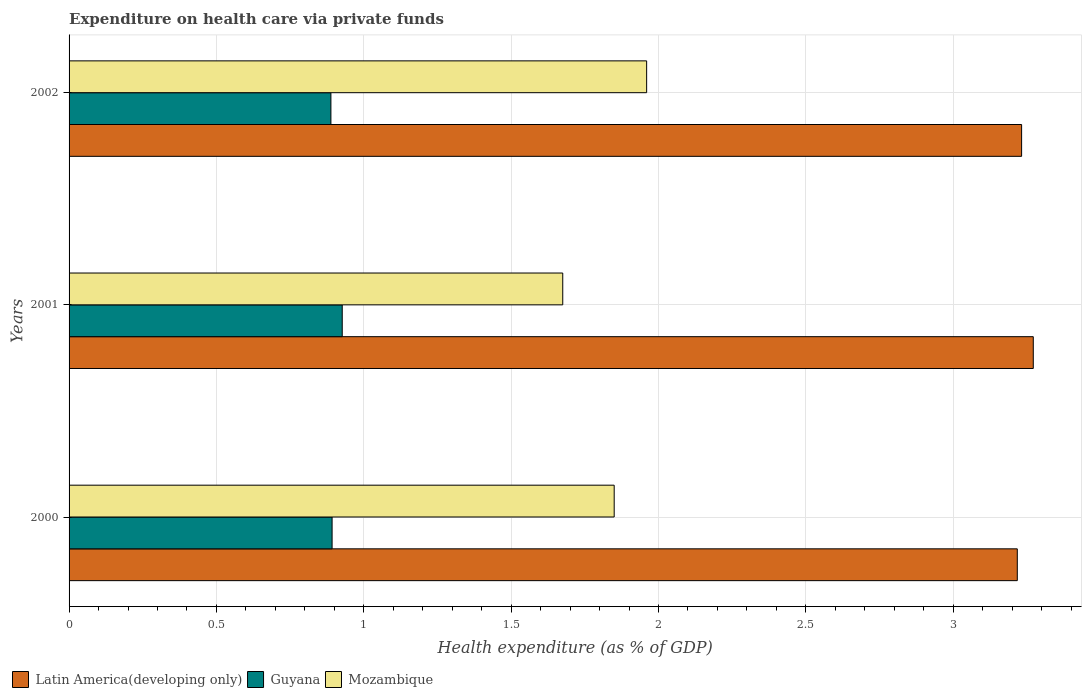How many different coloured bars are there?
Ensure brevity in your answer.  3. How many groups of bars are there?
Give a very brief answer. 3. How many bars are there on the 2nd tick from the top?
Ensure brevity in your answer.  3. In how many cases, is the number of bars for a given year not equal to the number of legend labels?
Give a very brief answer. 0. What is the expenditure made on health care in Guyana in 2000?
Give a very brief answer. 0.89. Across all years, what is the maximum expenditure made on health care in Guyana?
Keep it short and to the point. 0.93. Across all years, what is the minimum expenditure made on health care in Mozambique?
Make the answer very short. 1.68. In which year was the expenditure made on health care in Latin America(developing only) maximum?
Your response must be concise. 2001. What is the total expenditure made on health care in Guyana in the graph?
Provide a short and direct response. 2.71. What is the difference between the expenditure made on health care in Mozambique in 2000 and that in 2001?
Your answer should be very brief. 0.17. What is the difference between the expenditure made on health care in Guyana in 2000 and the expenditure made on health care in Latin America(developing only) in 2002?
Provide a succinct answer. -2.34. What is the average expenditure made on health care in Guyana per year?
Make the answer very short. 0.9. In the year 2001, what is the difference between the expenditure made on health care in Mozambique and expenditure made on health care in Latin America(developing only)?
Keep it short and to the point. -1.6. In how many years, is the expenditure made on health care in Guyana greater than 2.5 %?
Offer a terse response. 0. What is the ratio of the expenditure made on health care in Mozambique in 2000 to that in 2002?
Keep it short and to the point. 0.94. Is the expenditure made on health care in Latin America(developing only) in 2001 less than that in 2002?
Ensure brevity in your answer.  No. What is the difference between the highest and the second highest expenditure made on health care in Mozambique?
Give a very brief answer. 0.11. What is the difference between the highest and the lowest expenditure made on health care in Mozambique?
Make the answer very short. 0.28. In how many years, is the expenditure made on health care in Mozambique greater than the average expenditure made on health care in Mozambique taken over all years?
Ensure brevity in your answer.  2. Is the sum of the expenditure made on health care in Mozambique in 2001 and 2002 greater than the maximum expenditure made on health care in Guyana across all years?
Make the answer very short. Yes. What does the 2nd bar from the top in 2002 represents?
Offer a terse response. Guyana. What does the 3rd bar from the bottom in 2000 represents?
Your response must be concise. Mozambique. Is it the case that in every year, the sum of the expenditure made on health care in Mozambique and expenditure made on health care in Guyana is greater than the expenditure made on health care in Latin America(developing only)?
Offer a very short reply. No. How many bars are there?
Provide a succinct answer. 9. Are all the bars in the graph horizontal?
Provide a short and direct response. Yes. How many years are there in the graph?
Your answer should be compact. 3. Does the graph contain any zero values?
Keep it short and to the point. No. Where does the legend appear in the graph?
Ensure brevity in your answer.  Bottom left. What is the title of the graph?
Make the answer very short. Expenditure on health care via private funds. Does "Belgium" appear as one of the legend labels in the graph?
Provide a short and direct response. No. What is the label or title of the X-axis?
Provide a succinct answer. Health expenditure (as % of GDP). What is the Health expenditure (as % of GDP) in Latin America(developing only) in 2000?
Your answer should be compact. 3.22. What is the Health expenditure (as % of GDP) of Guyana in 2000?
Offer a very short reply. 0.89. What is the Health expenditure (as % of GDP) of Mozambique in 2000?
Make the answer very short. 1.85. What is the Health expenditure (as % of GDP) in Latin America(developing only) in 2001?
Give a very brief answer. 3.27. What is the Health expenditure (as % of GDP) of Guyana in 2001?
Keep it short and to the point. 0.93. What is the Health expenditure (as % of GDP) of Mozambique in 2001?
Give a very brief answer. 1.68. What is the Health expenditure (as % of GDP) of Latin America(developing only) in 2002?
Offer a very short reply. 3.23. What is the Health expenditure (as % of GDP) of Guyana in 2002?
Your answer should be compact. 0.89. What is the Health expenditure (as % of GDP) in Mozambique in 2002?
Your answer should be compact. 1.96. Across all years, what is the maximum Health expenditure (as % of GDP) in Latin America(developing only)?
Ensure brevity in your answer.  3.27. Across all years, what is the maximum Health expenditure (as % of GDP) in Guyana?
Make the answer very short. 0.93. Across all years, what is the maximum Health expenditure (as % of GDP) of Mozambique?
Keep it short and to the point. 1.96. Across all years, what is the minimum Health expenditure (as % of GDP) in Latin America(developing only)?
Ensure brevity in your answer.  3.22. Across all years, what is the minimum Health expenditure (as % of GDP) in Guyana?
Provide a succinct answer. 0.89. Across all years, what is the minimum Health expenditure (as % of GDP) in Mozambique?
Provide a succinct answer. 1.68. What is the total Health expenditure (as % of GDP) of Latin America(developing only) in the graph?
Your answer should be very brief. 9.72. What is the total Health expenditure (as % of GDP) in Guyana in the graph?
Ensure brevity in your answer.  2.71. What is the total Health expenditure (as % of GDP) of Mozambique in the graph?
Offer a terse response. 5.48. What is the difference between the Health expenditure (as % of GDP) in Latin America(developing only) in 2000 and that in 2001?
Provide a succinct answer. -0.05. What is the difference between the Health expenditure (as % of GDP) of Guyana in 2000 and that in 2001?
Offer a very short reply. -0.03. What is the difference between the Health expenditure (as % of GDP) of Mozambique in 2000 and that in 2001?
Provide a succinct answer. 0.17. What is the difference between the Health expenditure (as % of GDP) in Latin America(developing only) in 2000 and that in 2002?
Offer a very short reply. -0.01. What is the difference between the Health expenditure (as % of GDP) of Guyana in 2000 and that in 2002?
Keep it short and to the point. 0. What is the difference between the Health expenditure (as % of GDP) of Mozambique in 2000 and that in 2002?
Your response must be concise. -0.11. What is the difference between the Health expenditure (as % of GDP) in Latin America(developing only) in 2001 and that in 2002?
Offer a terse response. 0.04. What is the difference between the Health expenditure (as % of GDP) in Guyana in 2001 and that in 2002?
Your answer should be compact. 0.04. What is the difference between the Health expenditure (as % of GDP) in Mozambique in 2001 and that in 2002?
Keep it short and to the point. -0.28. What is the difference between the Health expenditure (as % of GDP) of Latin America(developing only) in 2000 and the Health expenditure (as % of GDP) of Guyana in 2001?
Offer a very short reply. 2.29. What is the difference between the Health expenditure (as % of GDP) in Latin America(developing only) in 2000 and the Health expenditure (as % of GDP) in Mozambique in 2001?
Make the answer very short. 1.54. What is the difference between the Health expenditure (as % of GDP) of Guyana in 2000 and the Health expenditure (as % of GDP) of Mozambique in 2001?
Offer a very short reply. -0.78. What is the difference between the Health expenditure (as % of GDP) in Latin America(developing only) in 2000 and the Health expenditure (as % of GDP) in Guyana in 2002?
Provide a short and direct response. 2.33. What is the difference between the Health expenditure (as % of GDP) of Latin America(developing only) in 2000 and the Health expenditure (as % of GDP) of Mozambique in 2002?
Your answer should be compact. 1.26. What is the difference between the Health expenditure (as % of GDP) in Guyana in 2000 and the Health expenditure (as % of GDP) in Mozambique in 2002?
Keep it short and to the point. -1.07. What is the difference between the Health expenditure (as % of GDP) in Latin America(developing only) in 2001 and the Health expenditure (as % of GDP) in Guyana in 2002?
Offer a terse response. 2.38. What is the difference between the Health expenditure (as % of GDP) in Latin America(developing only) in 2001 and the Health expenditure (as % of GDP) in Mozambique in 2002?
Your response must be concise. 1.31. What is the difference between the Health expenditure (as % of GDP) in Guyana in 2001 and the Health expenditure (as % of GDP) in Mozambique in 2002?
Provide a short and direct response. -1.03. What is the average Health expenditure (as % of GDP) of Latin America(developing only) per year?
Make the answer very short. 3.24. What is the average Health expenditure (as % of GDP) in Guyana per year?
Your answer should be very brief. 0.9. What is the average Health expenditure (as % of GDP) of Mozambique per year?
Your response must be concise. 1.83. In the year 2000, what is the difference between the Health expenditure (as % of GDP) in Latin America(developing only) and Health expenditure (as % of GDP) in Guyana?
Provide a succinct answer. 2.33. In the year 2000, what is the difference between the Health expenditure (as % of GDP) of Latin America(developing only) and Health expenditure (as % of GDP) of Mozambique?
Ensure brevity in your answer.  1.37. In the year 2000, what is the difference between the Health expenditure (as % of GDP) of Guyana and Health expenditure (as % of GDP) of Mozambique?
Provide a succinct answer. -0.96. In the year 2001, what is the difference between the Health expenditure (as % of GDP) of Latin America(developing only) and Health expenditure (as % of GDP) of Guyana?
Keep it short and to the point. 2.34. In the year 2001, what is the difference between the Health expenditure (as % of GDP) of Latin America(developing only) and Health expenditure (as % of GDP) of Mozambique?
Your response must be concise. 1.6. In the year 2001, what is the difference between the Health expenditure (as % of GDP) in Guyana and Health expenditure (as % of GDP) in Mozambique?
Provide a short and direct response. -0.75. In the year 2002, what is the difference between the Health expenditure (as % of GDP) in Latin America(developing only) and Health expenditure (as % of GDP) in Guyana?
Provide a short and direct response. 2.34. In the year 2002, what is the difference between the Health expenditure (as % of GDP) in Latin America(developing only) and Health expenditure (as % of GDP) in Mozambique?
Give a very brief answer. 1.27. In the year 2002, what is the difference between the Health expenditure (as % of GDP) of Guyana and Health expenditure (as % of GDP) of Mozambique?
Your response must be concise. -1.07. What is the ratio of the Health expenditure (as % of GDP) in Latin America(developing only) in 2000 to that in 2001?
Your answer should be very brief. 0.98. What is the ratio of the Health expenditure (as % of GDP) in Guyana in 2000 to that in 2001?
Provide a short and direct response. 0.96. What is the ratio of the Health expenditure (as % of GDP) in Mozambique in 2000 to that in 2001?
Offer a very short reply. 1.1. What is the ratio of the Health expenditure (as % of GDP) of Guyana in 2000 to that in 2002?
Keep it short and to the point. 1. What is the ratio of the Health expenditure (as % of GDP) in Mozambique in 2000 to that in 2002?
Offer a very short reply. 0.94. What is the ratio of the Health expenditure (as % of GDP) of Latin America(developing only) in 2001 to that in 2002?
Your response must be concise. 1.01. What is the ratio of the Health expenditure (as % of GDP) in Guyana in 2001 to that in 2002?
Your answer should be very brief. 1.04. What is the ratio of the Health expenditure (as % of GDP) in Mozambique in 2001 to that in 2002?
Your response must be concise. 0.85. What is the difference between the highest and the second highest Health expenditure (as % of GDP) of Latin America(developing only)?
Provide a succinct answer. 0.04. What is the difference between the highest and the second highest Health expenditure (as % of GDP) in Guyana?
Give a very brief answer. 0.03. What is the difference between the highest and the second highest Health expenditure (as % of GDP) in Mozambique?
Your response must be concise. 0.11. What is the difference between the highest and the lowest Health expenditure (as % of GDP) of Latin America(developing only)?
Keep it short and to the point. 0.05. What is the difference between the highest and the lowest Health expenditure (as % of GDP) of Guyana?
Your response must be concise. 0.04. What is the difference between the highest and the lowest Health expenditure (as % of GDP) of Mozambique?
Ensure brevity in your answer.  0.28. 